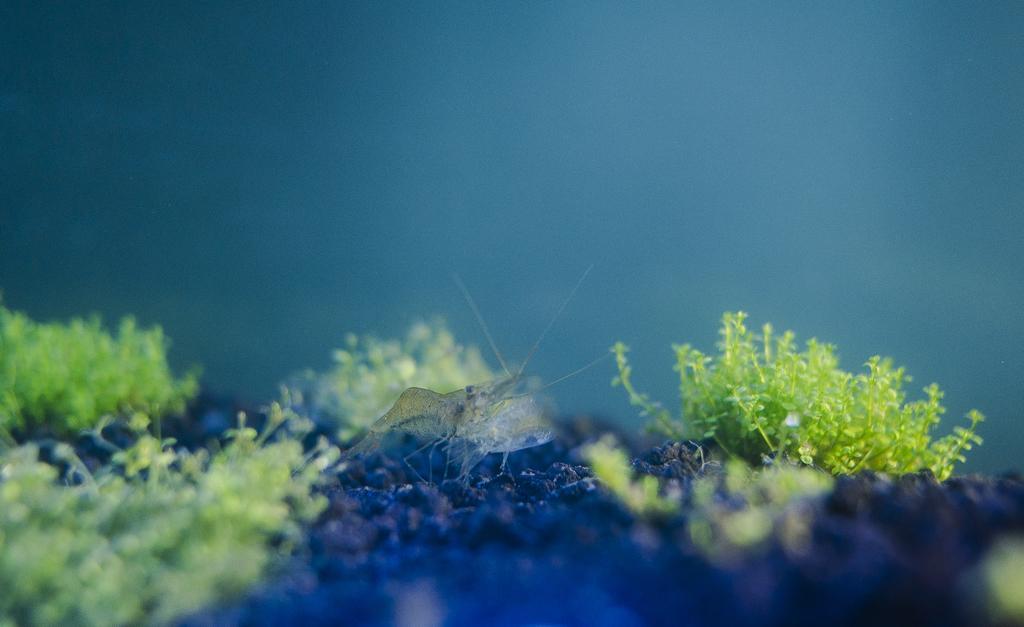How would you summarize this image in a sentence or two? In the image there is a insect standing on the land with small trees on either side of it and the background it blur. 